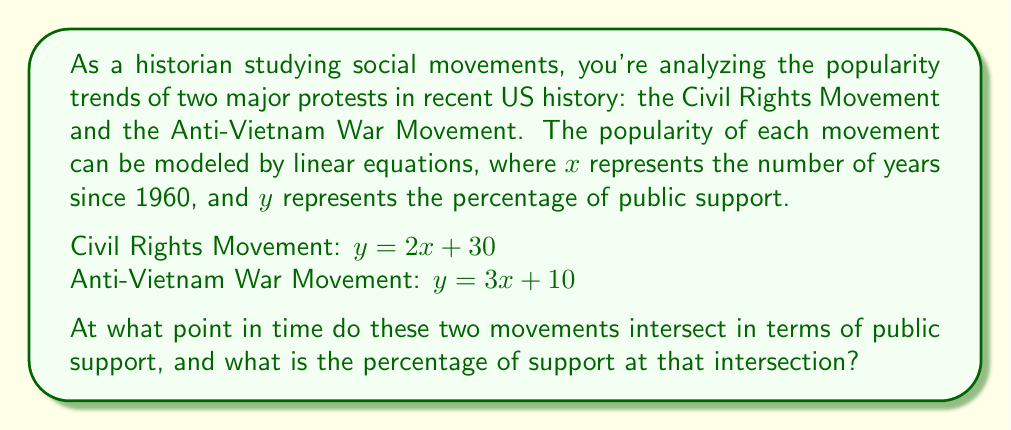Could you help me with this problem? To find the intersection point of these two trend lines, we need to solve the system of equations:

$$\begin{cases}
y = 2x + 30 \\
y = 3x + 10
\end{cases}$$

1) Since both equations equal $y$, we can set them equal to each other:
   $2x + 30 = 3x + 10$

2) Subtract $2x$ from both sides:
   $30 = x + 10$

3) Subtract 10 from both sides:
   $20 = x$

4) Now that we know $x$, we can substitute it into either of the original equations. Let's use the Civil Rights Movement equation:
   $y = 2(20) + 30 = 40 + 30 = 70$

5) To convert $x$ back to a year, remember that $x$ represents years since 1960. So:
   Year = 1960 + 20 = 1980

Therefore, the movements intersect in 1980 with 70% public support.
Answer: The two movements intersect in 1980 with 70% public support. 